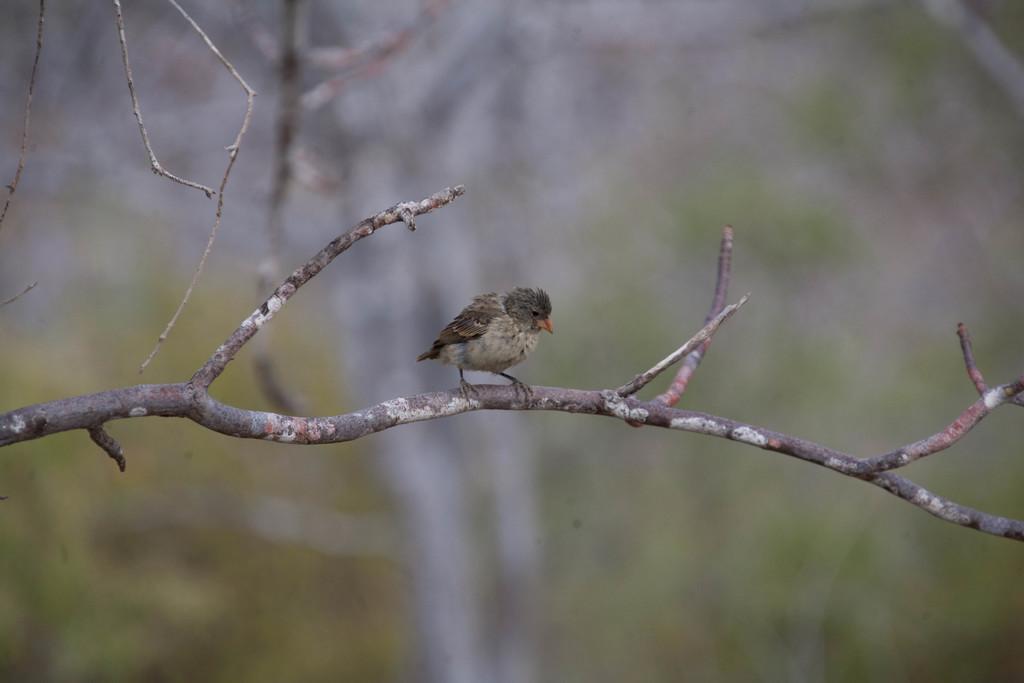Could you give a brief overview of what you see in this image? In this picture I can see a branch and on it I see a bird and I see that it is blurred in the background. 